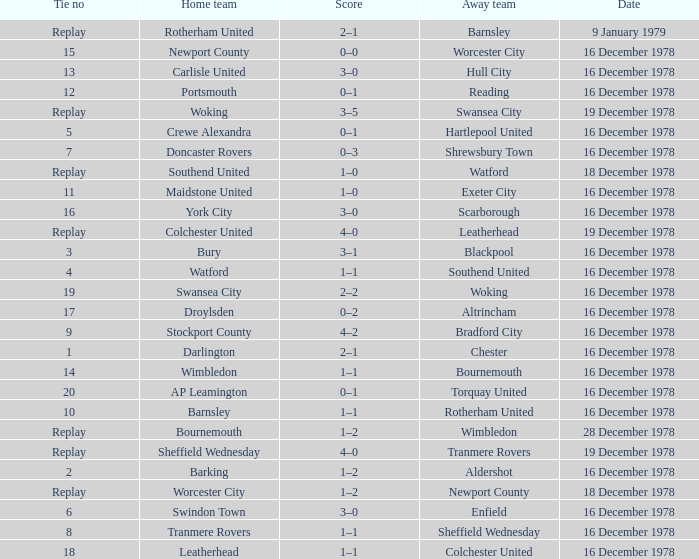Who was the opposing team when colchester united was the home team? Leatherhead. 